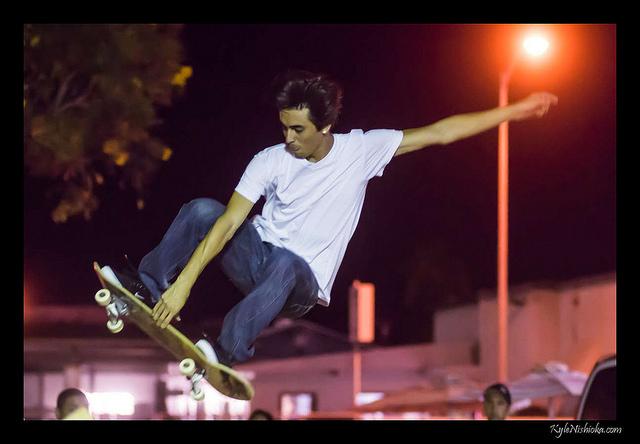Is this man falling off his board?
Be succinct. No. What is the skateboarder wearing?
Keep it brief. White shirt and jeans. Is he holding his skateboard?
Answer briefly. Yes. 